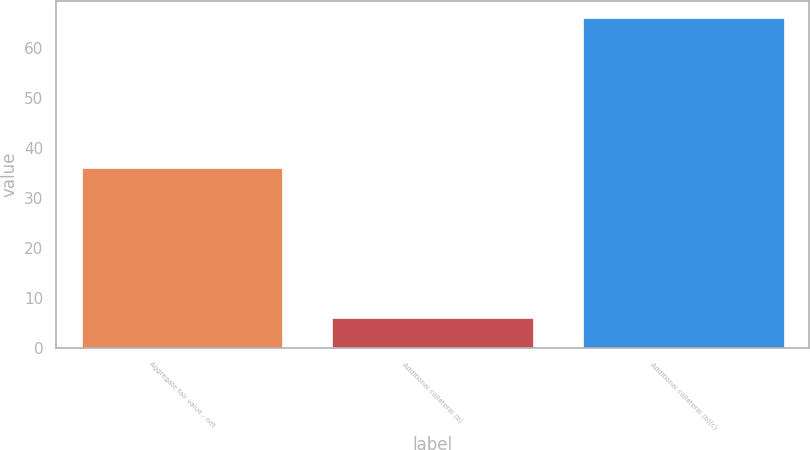Convert chart. <chart><loc_0><loc_0><loc_500><loc_500><bar_chart><fcel>Aggregate fair value - net<fcel>Additional collateral (b)<fcel>Additional collateral (b)(c)<nl><fcel>36<fcel>6<fcel>66<nl></chart> 